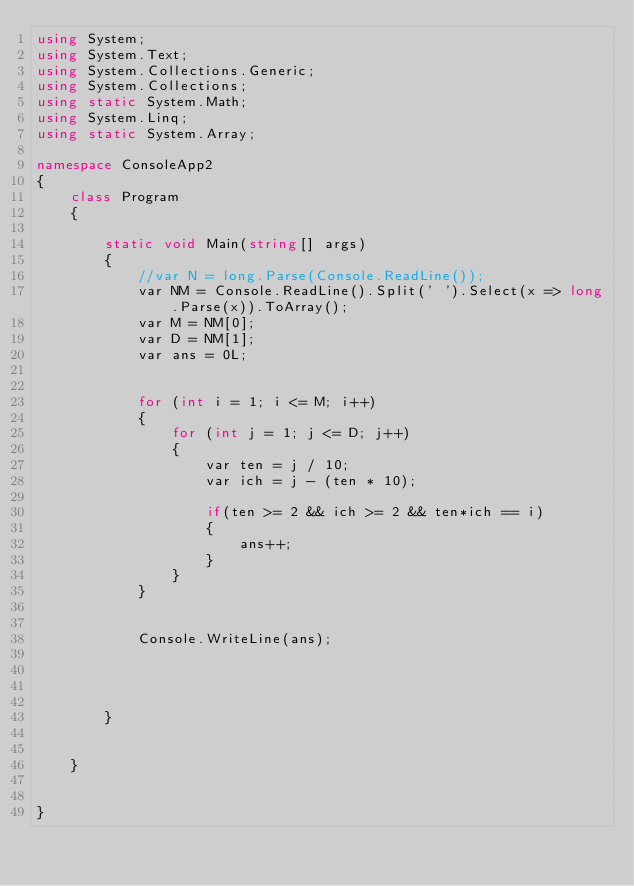<code> <loc_0><loc_0><loc_500><loc_500><_C#_>using System;
using System.Text;
using System.Collections.Generic;
using System.Collections;
using static System.Math;
using System.Linq;
using static System.Array;

namespace ConsoleApp2
{
    class Program
    {

        static void Main(string[] args)
        {
            //var N = long.Parse(Console.ReadLine());
            var NM = Console.ReadLine().Split(' ').Select(x => long.Parse(x)).ToArray();
            var M = NM[0];
            var D = NM[1];
            var ans = 0L;


            for (int i = 1; i <= M; i++)
            {
                for (int j = 1; j <= D; j++)
                {
                    var ten = j / 10;
                    var ich = j - (ten * 10);

                    if(ten >= 2 && ich >= 2 && ten*ich == i)
                    {
                        ans++;
                    }
                }
            }


            Console.WriteLine(ans);
            

            
            
        }


    }


}
</code> 